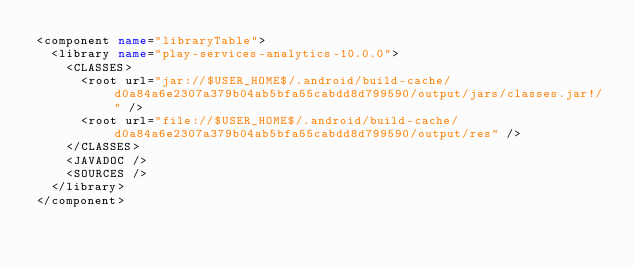Convert code to text. <code><loc_0><loc_0><loc_500><loc_500><_XML_><component name="libraryTable">
  <library name="play-services-analytics-10.0.0">
    <CLASSES>
      <root url="jar://$USER_HOME$/.android/build-cache/d0a84a6e2307a379b04ab5bfa55cabdd8d799590/output/jars/classes.jar!/" />
      <root url="file://$USER_HOME$/.android/build-cache/d0a84a6e2307a379b04ab5bfa55cabdd8d799590/output/res" />
    </CLASSES>
    <JAVADOC />
    <SOURCES />
  </library>
</component></code> 